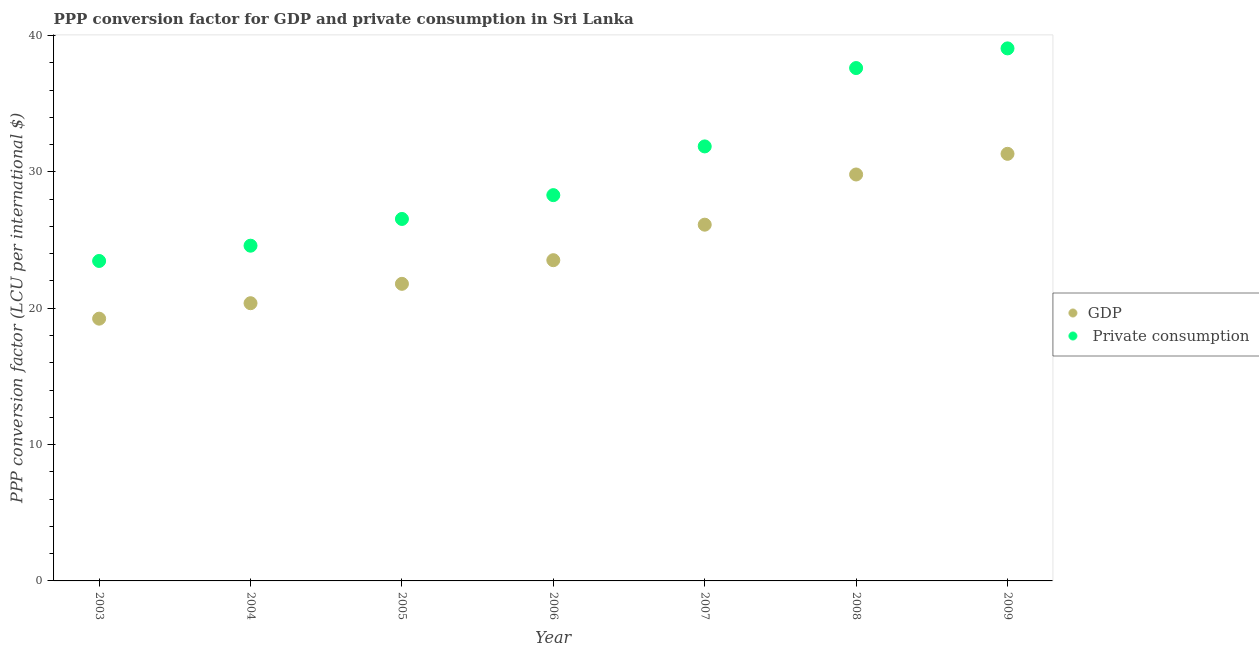How many different coloured dotlines are there?
Offer a terse response. 2. What is the ppp conversion factor for gdp in 2009?
Give a very brief answer. 31.32. Across all years, what is the maximum ppp conversion factor for gdp?
Give a very brief answer. 31.32. Across all years, what is the minimum ppp conversion factor for gdp?
Provide a short and direct response. 19.23. In which year was the ppp conversion factor for gdp maximum?
Provide a short and direct response. 2009. In which year was the ppp conversion factor for gdp minimum?
Ensure brevity in your answer.  2003. What is the total ppp conversion factor for private consumption in the graph?
Offer a terse response. 211.41. What is the difference between the ppp conversion factor for private consumption in 2004 and that in 2009?
Your response must be concise. -14.47. What is the difference between the ppp conversion factor for private consumption in 2006 and the ppp conversion factor for gdp in 2004?
Give a very brief answer. 7.93. What is the average ppp conversion factor for gdp per year?
Make the answer very short. 24.59. In the year 2003, what is the difference between the ppp conversion factor for private consumption and ppp conversion factor for gdp?
Provide a short and direct response. 4.23. What is the ratio of the ppp conversion factor for gdp in 2003 to that in 2004?
Ensure brevity in your answer.  0.94. Is the ppp conversion factor for gdp in 2004 less than that in 2008?
Offer a terse response. Yes. Is the difference between the ppp conversion factor for gdp in 2003 and 2007 greater than the difference between the ppp conversion factor for private consumption in 2003 and 2007?
Your answer should be compact. Yes. What is the difference between the highest and the second highest ppp conversion factor for private consumption?
Provide a succinct answer. 1.44. What is the difference between the highest and the lowest ppp conversion factor for gdp?
Your response must be concise. 12.09. Does the ppp conversion factor for private consumption monotonically increase over the years?
Provide a short and direct response. Yes. How many dotlines are there?
Ensure brevity in your answer.  2. What is the difference between two consecutive major ticks on the Y-axis?
Your answer should be very brief. 10. Are the values on the major ticks of Y-axis written in scientific E-notation?
Keep it short and to the point. No. Where does the legend appear in the graph?
Your response must be concise. Center right. How many legend labels are there?
Your answer should be very brief. 2. How are the legend labels stacked?
Your answer should be very brief. Vertical. What is the title of the graph?
Offer a very short reply. PPP conversion factor for GDP and private consumption in Sri Lanka. Does "Boys" appear as one of the legend labels in the graph?
Your response must be concise. No. What is the label or title of the Y-axis?
Offer a terse response. PPP conversion factor (LCU per international $). What is the PPP conversion factor (LCU per international $) of GDP in 2003?
Your answer should be compact. 19.23. What is the PPP conversion factor (LCU per international $) of  Private consumption in 2003?
Your answer should be compact. 23.46. What is the PPP conversion factor (LCU per international $) of GDP in 2004?
Offer a terse response. 20.37. What is the PPP conversion factor (LCU per international $) of  Private consumption in 2004?
Your answer should be very brief. 24.58. What is the PPP conversion factor (LCU per international $) in GDP in 2005?
Keep it short and to the point. 21.79. What is the PPP conversion factor (LCU per international $) in  Private consumption in 2005?
Provide a short and direct response. 26.54. What is the PPP conversion factor (LCU per international $) of GDP in 2006?
Make the answer very short. 23.52. What is the PPP conversion factor (LCU per international $) of  Private consumption in 2006?
Your answer should be compact. 28.29. What is the PPP conversion factor (LCU per international $) of GDP in 2007?
Provide a short and direct response. 26.12. What is the PPP conversion factor (LCU per international $) of  Private consumption in 2007?
Your answer should be compact. 31.86. What is the PPP conversion factor (LCU per international $) in GDP in 2008?
Offer a very short reply. 29.8. What is the PPP conversion factor (LCU per international $) of  Private consumption in 2008?
Make the answer very short. 37.61. What is the PPP conversion factor (LCU per international $) in GDP in 2009?
Make the answer very short. 31.32. What is the PPP conversion factor (LCU per international $) in  Private consumption in 2009?
Provide a succinct answer. 39.05. Across all years, what is the maximum PPP conversion factor (LCU per international $) of GDP?
Provide a succinct answer. 31.32. Across all years, what is the maximum PPP conversion factor (LCU per international $) in  Private consumption?
Offer a terse response. 39.05. Across all years, what is the minimum PPP conversion factor (LCU per international $) in GDP?
Offer a very short reply. 19.23. Across all years, what is the minimum PPP conversion factor (LCU per international $) of  Private consumption?
Your answer should be very brief. 23.46. What is the total PPP conversion factor (LCU per international $) of GDP in the graph?
Provide a succinct answer. 172.15. What is the total PPP conversion factor (LCU per international $) of  Private consumption in the graph?
Your answer should be compact. 211.41. What is the difference between the PPP conversion factor (LCU per international $) of GDP in 2003 and that in 2004?
Give a very brief answer. -1.13. What is the difference between the PPP conversion factor (LCU per international $) of  Private consumption in 2003 and that in 2004?
Offer a very short reply. -1.12. What is the difference between the PPP conversion factor (LCU per international $) of GDP in 2003 and that in 2005?
Make the answer very short. -2.55. What is the difference between the PPP conversion factor (LCU per international $) of  Private consumption in 2003 and that in 2005?
Keep it short and to the point. -3.08. What is the difference between the PPP conversion factor (LCU per international $) in GDP in 2003 and that in 2006?
Your response must be concise. -4.29. What is the difference between the PPP conversion factor (LCU per international $) in  Private consumption in 2003 and that in 2006?
Keep it short and to the point. -4.83. What is the difference between the PPP conversion factor (LCU per international $) in GDP in 2003 and that in 2007?
Keep it short and to the point. -6.89. What is the difference between the PPP conversion factor (LCU per international $) of  Private consumption in 2003 and that in 2007?
Keep it short and to the point. -8.4. What is the difference between the PPP conversion factor (LCU per international $) of GDP in 2003 and that in 2008?
Offer a very short reply. -10.57. What is the difference between the PPP conversion factor (LCU per international $) in  Private consumption in 2003 and that in 2008?
Ensure brevity in your answer.  -14.15. What is the difference between the PPP conversion factor (LCU per international $) in GDP in 2003 and that in 2009?
Offer a terse response. -12.09. What is the difference between the PPP conversion factor (LCU per international $) in  Private consumption in 2003 and that in 2009?
Give a very brief answer. -15.59. What is the difference between the PPP conversion factor (LCU per international $) in GDP in 2004 and that in 2005?
Offer a terse response. -1.42. What is the difference between the PPP conversion factor (LCU per international $) of  Private consumption in 2004 and that in 2005?
Offer a terse response. -1.96. What is the difference between the PPP conversion factor (LCU per international $) in GDP in 2004 and that in 2006?
Offer a very short reply. -3.15. What is the difference between the PPP conversion factor (LCU per international $) of  Private consumption in 2004 and that in 2006?
Make the answer very short. -3.71. What is the difference between the PPP conversion factor (LCU per international $) in GDP in 2004 and that in 2007?
Offer a very short reply. -5.76. What is the difference between the PPP conversion factor (LCU per international $) in  Private consumption in 2004 and that in 2007?
Your answer should be compact. -7.28. What is the difference between the PPP conversion factor (LCU per international $) of GDP in 2004 and that in 2008?
Give a very brief answer. -9.44. What is the difference between the PPP conversion factor (LCU per international $) of  Private consumption in 2004 and that in 2008?
Your answer should be very brief. -13.03. What is the difference between the PPP conversion factor (LCU per international $) in GDP in 2004 and that in 2009?
Provide a succinct answer. -10.95. What is the difference between the PPP conversion factor (LCU per international $) of  Private consumption in 2004 and that in 2009?
Provide a succinct answer. -14.47. What is the difference between the PPP conversion factor (LCU per international $) in GDP in 2005 and that in 2006?
Ensure brevity in your answer.  -1.73. What is the difference between the PPP conversion factor (LCU per international $) in  Private consumption in 2005 and that in 2006?
Provide a short and direct response. -1.75. What is the difference between the PPP conversion factor (LCU per international $) in GDP in 2005 and that in 2007?
Ensure brevity in your answer.  -4.34. What is the difference between the PPP conversion factor (LCU per international $) of  Private consumption in 2005 and that in 2007?
Offer a terse response. -5.32. What is the difference between the PPP conversion factor (LCU per international $) of GDP in 2005 and that in 2008?
Offer a terse response. -8.02. What is the difference between the PPP conversion factor (LCU per international $) in  Private consumption in 2005 and that in 2008?
Offer a very short reply. -11.07. What is the difference between the PPP conversion factor (LCU per international $) of GDP in 2005 and that in 2009?
Your answer should be compact. -9.53. What is the difference between the PPP conversion factor (LCU per international $) of  Private consumption in 2005 and that in 2009?
Keep it short and to the point. -12.51. What is the difference between the PPP conversion factor (LCU per international $) in GDP in 2006 and that in 2007?
Your response must be concise. -2.6. What is the difference between the PPP conversion factor (LCU per international $) of  Private consumption in 2006 and that in 2007?
Offer a very short reply. -3.57. What is the difference between the PPP conversion factor (LCU per international $) in GDP in 2006 and that in 2008?
Your response must be concise. -6.28. What is the difference between the PPP conversion factor (LCU per international $) of  Private consumption in 2006 and that in 2008?
Make the answer very short. -9.32. What is the difference between the PPP conversion factor (LCU per international $) of GDP in 2006 and that in 2009?
Make the answer very short. -7.8. What is the difference between the PPP conversion factor (LCU per international $) in  Private consumption in 2006 and that in 2009?
Your answer should be compact. -10.76. What is the difference between the PPP conversion factor (LCU per international $) of GDP in 2007 and that in 2008?
Your answer should be very brief. -3.68. What is the difference between the PPP conversion factor (LCU per international $) in  Private consumption in 2007 and that in 2008?
Offer a very short reply. -5.75. What is the difference between the PPP conversion factor (LCU per international $) in GDP in 2007 and that in 2009?
Your answer should be very brief. -5.2. What is the difference between the PPP conversion factor (LCU per international $) of  Private consumption in 2007 and that in 2009?
Keep it short and to the point. -7.19. What is the difference between the PPP conversion factor (LCU per international $) of GDP in 2008 and that in 2009?
Provide a succinct answer. -1.51. What is the difference between the PPP conversion factor (LCU per international $) in  Private consumption in 2008 and that in 2009?
Offer a very short reply. -1.44. What is the difference between the PPP conversion factor (LCU per international $) in GDP in 2003 and the PPP conversion factor (LCU per international $) in  Private consumption in 2004?
Ensure brevity in your answer.  -5.35. What is the difference between the PPP conversion factor (LCU per international $) in GDP in 2003 and the PPP conversion factor (LCU per international $) in  Private consumption in 2005?
Offer a very short reply. -7.31. What is the difference between the PPP conversion factor (LCU per international $) of GDP in 2003 and the PPP conversion factor (LCU per international $) of  Private consumption in 2006?
Offer a terse response. -9.06. What is the difference between the PPP conversion factor (LCU per international $) in GDP in 2003 and the PPP conversion factor (LCU per international $) in  Private consumption in 2007?
Make the answer very short. -12.63. What is the difference between the PPP conversion factor (LCU per international $) of GDP in 2003 and the PPP conversion factor (LCU per international $) of  Private consumption in 2008?
Ensure brevity in your answer.  -18.38. What is the difference between the PPP conversion factor (LCU per international $) in GDP in 2003 and the PPP conversion factor (LCU per international $) in  Private consumption in 2009?
Your answer should be very brief. -19.82. What is the difference between the PPP conversion factor (LCU per international $) of GDP in 2004 and the PPP conversion factor (LCU per international $) of  Private consumption in 2005?
Ensure brevity in your answer.  -6.18. What is the difference between the PPP conversion factor (LCU per international $) in GDP in 2004 and the PPP conversion factor (LCU per international $) in  Private consumption in 2006?
Ensure brevity in your answer.  -7.93. What is the difference between the PPP conversion factor (LCU per international $) of GDP in 2004 and the PPP conversion factor (LCU per international $) of  Private consumption in 2007?
Make the answer very short. -11.5. What is the difference between the PPP conversion factor (LCU per international $) of GDP in 2004 and the PPP conversion factor (LCU per international $) of  Private consumption in 2008?
Offer a very short reply. -17.24. What is the difference between the PPP conversion factor (LCU per international $) in GDP in 2004 and the PPP conversion factor (LCU per international $) in  Private consumption in 2009?
Ensure brevity in your answer.  -18.69. What is the difference between the PPP conversion factor (LCU per international $) of GDP in 2005 and the PPP conversion factor (LCU per international $) of  Private consumption in 2006?
Your response must be concise. -6.51. What is the difference between the PPP conversion factor (LCU per international $) in GDP in 2005 and the PPP conversion factor (LCU per international $) in  Private consumption in 2007?
Your answer should be compact. -10.08. What is the difference between the PPP conversion factor (LCU per international $) in GDP in 2005 and the PPP conversion factor (LCU per international $) in  Private consumption in 2008?
Your answer should be very brief. -15.82. What is the difference between the PPP conversion factor (LCU per international $) of GDP in 2005 and the PPP conversion factor (LCU per international $) of  Private consumption in 2009?
Provide a succinct answer. -17.27. What is the difference between the PPP conversion factor (LCU per international $) of GDP in 2006 and the PPP conversion factor (LCU per international $) of  Private consumption in 2007?
Give a very brief answer. -8.34. What is the difference between the PPP conversion factor (LCU per international $) in GDP in 2006 and the PPP conversion factor (LCU per international $) in  Private consumption in 2008?
Your answer should be compact. -14.09. What is the difference between the PPP conversion factor (LCU per international $) of GDP in 2006 and the PPP conversion factor (LCU per international $) of  Private consumption in 2009?
Your response must be concise. -15.53. What is the difference between the PPP conversion factor (LCU per international $) of GDP in 2007 and the PPP conversion factor (LCU per international $) of  Private consumption in 2008?
Your answer should be compact. -11.49. What is the difference between the PPP conversion factor (LCU per international $) in GDP in 2007 and the PPP conversion factor (LCU per international $) in  Private consumption in 2009?
Ensure brevity in your answer.  -12.93. What is the difference between the PPP conversion factor (LCU per international $) in GDP in 2008 and the PPP conversion factor (LCU per international $) in  Private consumption in 2009?
Offer a terse response. -9.25. What is the average PPP conversion factor (LCU per international $) in GDP per year?
Offer a terse response. 24.59. What is the average PPP conversion factor (LCU per international $) in  Private consumption per year?
Your answer should be compact. 30.2. In the year 2003, what is the difference between the PPP conversion factor (LCU per international $) in GDP and PPP conversion factor (LCU per international $) in  Private consumption?
Your response must be concise. -4.23. In the year 2004, what is the difference between the PPP conversion factor (LCU per international $) of GDP and PPP conversion factor (LCU per international $) of  Private consumption?
Offer a terse response. -4.22. In the year 2005, what is the difference between the PPP conversion factor (LCU per international $) of GDP and PPP conversion factor (LCU per international $) of  Private consumption?
Give a very brief answer. -4.76. In the year 2006, what is the difference between the PPP conversion factor (LCU per international $) of GDP and PPP conversion factor (LCU per international $) of  Private consumption?
Offer a very short reply. -4.77. In the year 2007, what is the difference between the PPP conversion factor (LCU per international $) in GDP and PPP conversion factor (LCU per international $) in  Private consumption?
Your answer should be very brief. -5.74. In the year 2008, what is the difference between the PPP conversion factor (LCU per international $) of GDP and PPP conversion factor (LCU per international $) of  Private consumption?
Your answer should be compact. -7.8. In the year 2009, what is the difference between the PPP conversion factor (LCU per international $) of GDP and PPP conversion factor (LCU per international $) of  Private consumption?
Make the answer very short. -7.73. What is the ratio of the PPP conversion factor (LCU per international $) in  Private consumption in 2003 to that in 2004?
Your answer should be very brief. 0.95. What is the ratio of the PPP conversion factor (LCU per international $) of GDP in 2003 to that in 2005?
Offer a very short reply. 0.88. What is the ratio of the PPP conversion factor (LCU per international $) of  Private consumption in 2003 to that in 2005?
Provide a succinct answer. 0.88. What is the ratio of the PPP conversion factor (LCU per international $) in GDP in 2003 to that in 2006?
Offer a terse response. 0.82. What is the ratio of the PPP conversion factor (LCU per international $) in  Private consumption in 2003 to that in 2006?
Offer a very short reply. 0.83. What is the ratio of the PPP conversion factor (LCU per international $) of GDP in 2003 to that in 2007?
Provide a short and direct response. 0.74. What is the ratio of the PPP conversion factor (LCU per international $) of  Private consumption in 2003 to that in 2007?
Provide a short and direct response. 0.74. What is the ratio of the PPP conversion factor (LCU per international $) in GDP in 2003 to that in 2008?
Give a very brief answer. 0.65. What is the ratio of the PPP conversion factor (LCU per international $) of  Private consumption in 2003 to that in 2008?
Provide a short and direct response. 0.62. What is the ratio of the PPP conversion factor (LCU per international $) of GDP in 2003 to that in 2009?
Your answer should be very brief. 0.61. What is the ratio of the PPP conversion factor (LCU per international $) of  Private consumption in 2003 to that in 2009?
Your answer should be compact. 0.6. What is the ratio of the PPP conversion factor (LCU per international $) of GDP in 2004 to that in 2005?
Give a very brief answer. 0.93. What is the ratio of the PPP conversion factor (LCU per international $) in  Private consumption in 2004 to that in 2005?
Provide a succinct answer. 0.93. What is the ratio of the PPP conversion factor (LCU per international $) in GDP in 2004 to that in 2006?
Your answer should be compact. 0.87. What is the ratio of the PPP conversion factor (LCU per international $) in  Private consumption in 2004 to that in 2006?
Offer a very short reply. 0.87. What is the ratio of the PPP conversion factor (LCU per international $) in GDP in 2004 to that in 2007?
Provide a succinct answer. 0.78. What is the ratio of the PPP conversion factor (LCU per international $) in  Private consumption in 2004 to that in 2007?
Offer a terse response. 0.77. What is the ratio of the PPP conversion factor (LCU per international $) of GDP in 2004 to that in 2008?
Offer a terse response. 0.68. What is the ratio of the PPP conversion factor (LCU per international $) in  Private consumption in 2004 to that in 2008?
Offer a terse response. 0.65. What is the ratio of the PPP conversion factor (LCU per international $) of GDP in 2004 to that in 2009?
Your answer should be very brief. 0.65. What is the ratio of the PPP conversion factor (LCU per international $) of  Private consumption in 2004 to that in 2009?
Give a very brief answer. 0.63. What is the ratio of the PPP conversion factor (LCU per international $) of GDP in 2005 to that in 2006?
Provide a short and direct response. 0.93. What is the ratio of the PPP conversion factor (LCU per international $) of  Private consumption in 2005 to that in 2006?
Give a very brief answer. 0.94. What is the ratio of the PPP conversion factor (LCU per international $) in GDP in 2005 to that in 2007?
Ensure brevity in your answer.  0.83. What is the ratio of the PPP conversion factor (LCU per international $) of  Private consumption in 2005 to that in 2007?
Provide a short and direct response. 0.83. What is the ratio of the PPP conversion factor (LCU per international $) in GDP in 2005 to that in 2008?
Provide a short and direct response. 0.73. What is the ratio of the PPP conversion factor (LCU per international $) of  Private consumption in 2005 to that in 2008?
Provide a short and direct response. 0.71. What is the ratio of the PPP conversion factor (LCU per international $) in GDP in 2005 to that in 2009?
Provide a succinct answer. 0.7. What is the ratio of the PPP conversion factor (LCU per international $) in  Private consumption in 2005 to that in 2009?
Your answer should be very brief. 0.68. What is the ratio of the PPP conversion factor (LCU per international $) in GDP in 2006 to that in 2007?
Offer a very short reply. 0.9. What is the ratio of the PPP conversion factor (LCU per international $) in  Private consumption in 2006 to that in 2007?
Give a very brief answer. 0.89. What is the ratio of the PPP conversion factor (LCU per international $) in GDP in 2006 to that in 2008?
Your response must be concise. 0.79. What is the ratio of the PPP conversion factor (LCU per international $) of  Private consumption in 2006 to that in 2008?
Your response must be concise. 0.75. What is the ratio of the PPP conversion factor (LCU per international $) in GDP in 2006 to that in 2009?
Offer a very short reply. 0.75. What is the ratio of the PPP conversion factor (LCU per international $) in  Private consumption in 2006 to that in 2009?
Give a very brief answer. 0.72. What is the ratio of the PPP conversion factor (LCU per international $) of GDP in 2007 to that in 2008?
Give a very brief answer. 0.88. What is the ratio of the PPP conversion factor (LCU per international $) in  Private consumption in 2007 to that in 2008?
Your response must be concise. 0.85. What is the ratio of the PPP conversion factor (LCU per international $) of GDP in 2007 to that in 2009?
Provide a succinct answer. 0.83. What is the ratio of the PPP conversion factor (LCU per international $) in  Private consumption in 2007 to that in 2009?
Offer a very short reply. 0.82. What is the ratio of the PPP conversion factor (LCU per international $) in GDP in 2008 to that in 2009?
Your answer should be compact. 0.95. What is the ratio of the PPP conversion factor (LCU per international $) of  Private consumption in 2008 to that in 2009?
Your response must be concise. 0.96. What is the difference between the highest and the second highest PPP conversion factor (LCU per international $) of GDP?
Offer a very short reply. 1.51. What is the difference between the highest and the second highest PPP conversion factor (LCU per international $) of  Private consumption?
Your response must be concise. 1.44. What is the difference between the highest and the lowest PPP conversion factor (LCU per international $) in GDP?
Offer a terse response. 12.09. What is the difference between the highest and the lowest PPP conversion factor (LCU per international $) of  Private consumption?
Your answer should be very brief. 15.59. 